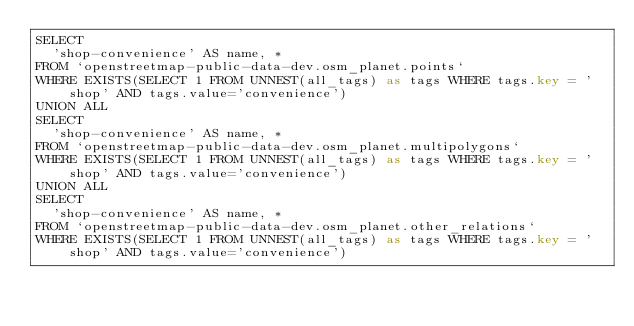<code> <loc_0><loc_0><loc_500><loc_500><_SQL_>SELECT
  'shop-convenience' AS name, *
FROM `openstreetmap-public-data-dev.osm_planet.points`
WHERE EXISTS(SELECT 1 FROM UNNEST(all_tags) as tags WHERE tags.key = 'shop' AND tags.value='convenience')
UNION ALL
SELECT
  'shop-convenience' AS name, *
FROM `openstreetmap-public-data-dev.osm_planet.multipolygons`
WHERE EXISTS(SELECT 1 FROM UNNEST(all_tags) as tags WHERE tags.key = 'shop' AND tags.value='convenience')
UNION ALL
SELECT
  'shop-convenience' AS name, *
FROM `openstreetmap-public-data-dev.osm_planet.other_relations`
WHERE EXISTS(SELECT 1 FROM UNNEST(all_tags) as tags WHERE tags.key = 'shop' AND tags.value='convenience')

</code> 